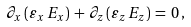Convert formula to latex. <formula><loc_0><loc_0><loc_500><loc_500>\partial _ { x } \, ( \varepsilon _ { x } \, E _ { x } ) \, + \, \partial _ { z } \, ( \varepsilon _ { z } \, E _ { z } ) \, = \, 0 \, ,</formula> 